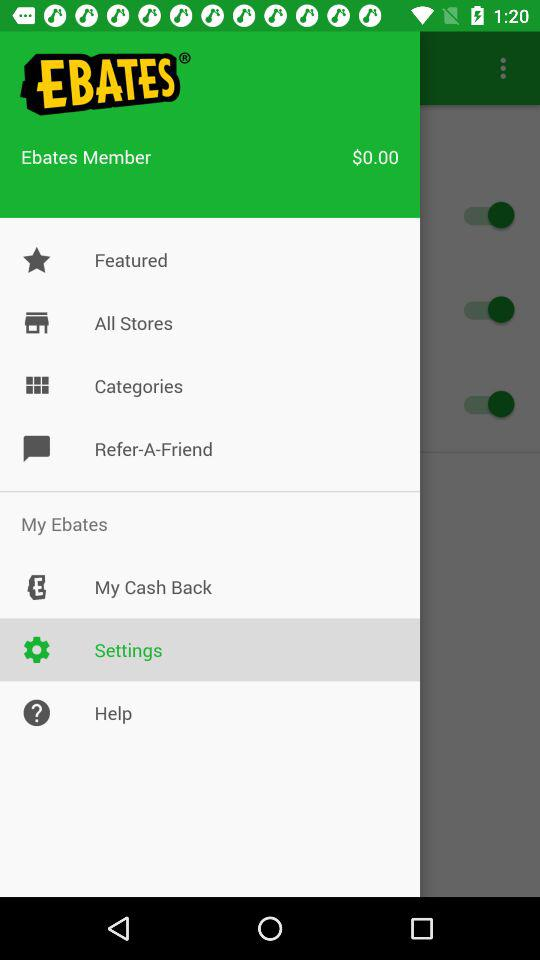How much cash back do I have?
Answer the question using a single word or phrase. $0.00 